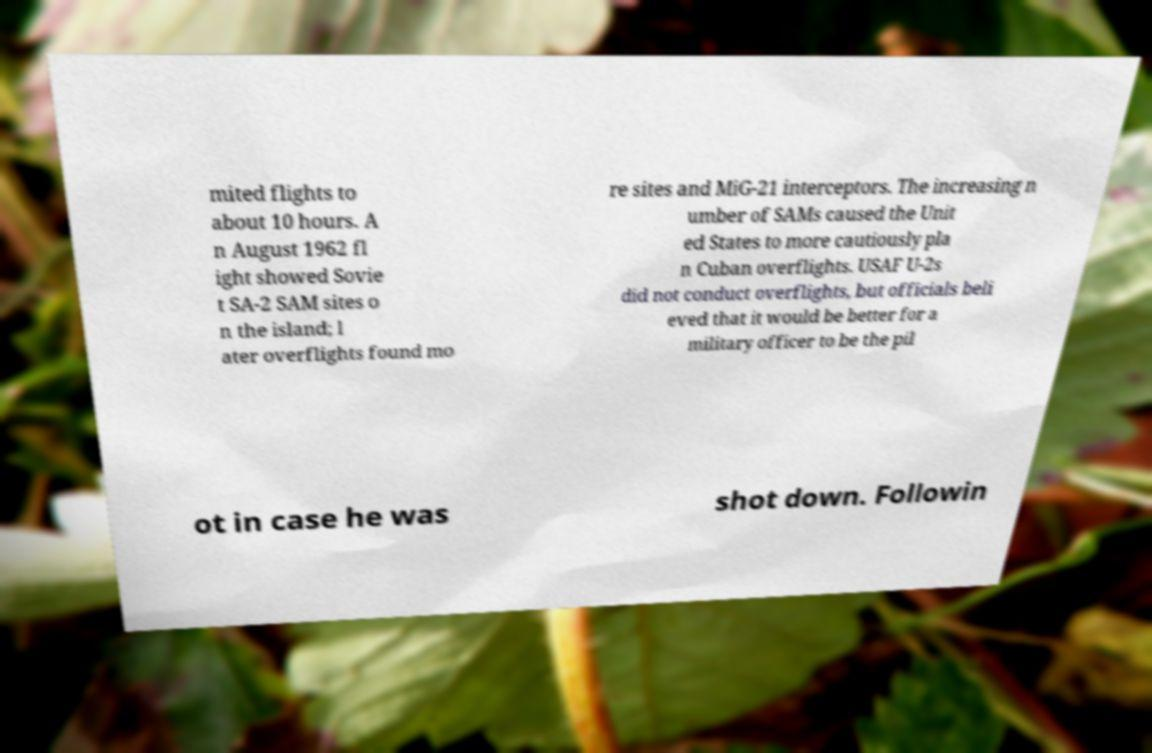Could you assist in decoding the text presented in this image and type it out clearly? mited flights to about 10 hours. A n August 1962 fl ight showed Sovie t SA-2 SAM sites o n the island; l ater overflights found mo re sites and MiG-21 interceptors. The increasing n umber of SAMs caused the Unit ed States to more cautiously pla n Cuban overflights. USAF U-2s did not conduct overflights, but officials beli eved that it would be better for a military officer to be the pil ot in case he was shot down. Followin 